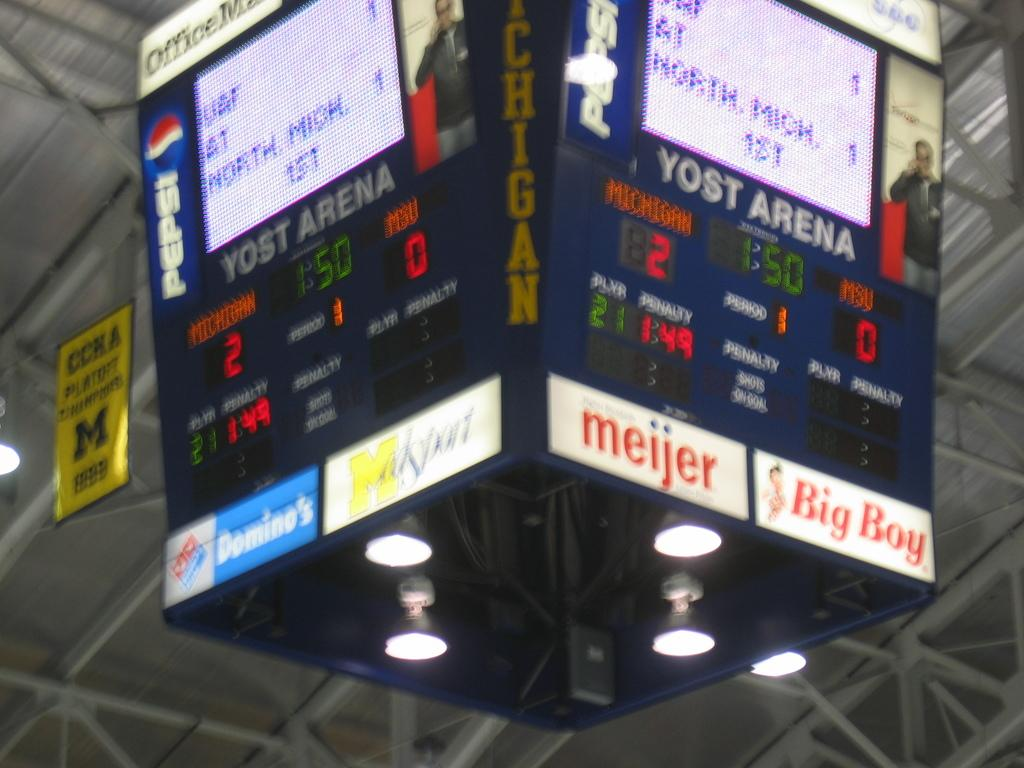Provide a one-sentence caption for the provided image. Scoreboard in a sports game that says YOST Arena. 